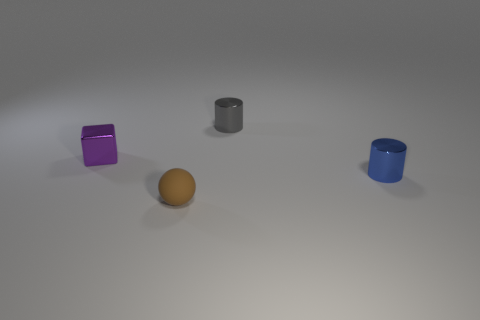How many small objects are in front of the small purple metallic block and behind the small brown ball?
Your answer should be compact. 1. There is a tiny metal thing that is in front of the purple metal cube; what is its color?
Your answer should be very brief. Blue. What is the size of the blue cylinder that is the same material as the tiny gray cylinder?
Keep it short and to the point. Small. There is a small cylinder in front of the gray shiny cylinder; how many small brown balls are left of it?
Your answer should be compact. 1. There is a tiny block; what number of brown objects are on the left side of it?
Your response must be concise. 0. What color is the shiny thing in front of the thing on the left side of the matte ball that is to the right of the small purple metallic thing?
Your answer should be compact. Blue. What is the shape of the tiny metallic object that is behind the small shiny thing to the left of the ball?
Make the answer very short. Cylinder. Is there a blue cylinder that has the same size as the purple shiny thing?
Keep it short and to the point. Yes. How many blue shiny objects are the same shape as the small gray thing?
Offer a terse response. 1. Is the number of brown matte balls that are behind the blue metal thing the same as the number of cylinders in front of the sphere?
Provide a short and direct response. Yes. 